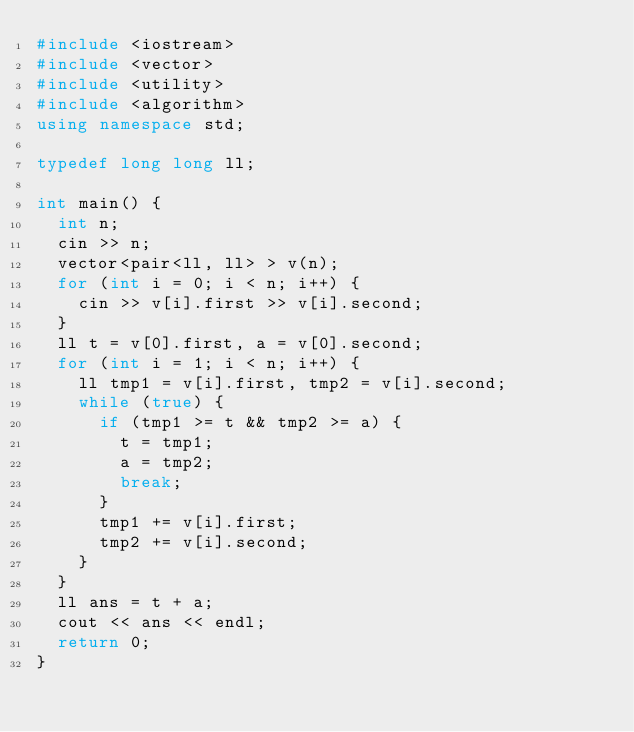Convert code to text. <code><loc_0><loc_0><loc_500><loc_500><_C++_>#include <iostream>
#include <vector>
#include <utility>
#include <algorithm>
using namespace std;

typedef long long ll;

int main() {
  int n;
  cin >> n;
  vector<pair<ll, ll> > v(n);
  for (int i = 0; i < n; i++) {
    cin >> v[i].first >> v[i].second;
  }
  ll t = v[0].first, a = v[0].second;
  for (int i = 1; i < n; i++) {
    ll tmp1 = v[i].first, tmp2 = v[i].second;
    while (true) {
      if (tmp1 >= t && tmp2 >= a) {
        t = tmp1;
        a = tmp2;
        break;
      }
      tmp1 += v[i].first;
      tmp2 += v[i].second;
    }
  }
  ll ans = t + a;
  cout << ans << endl;
  return 0;
}</code> 